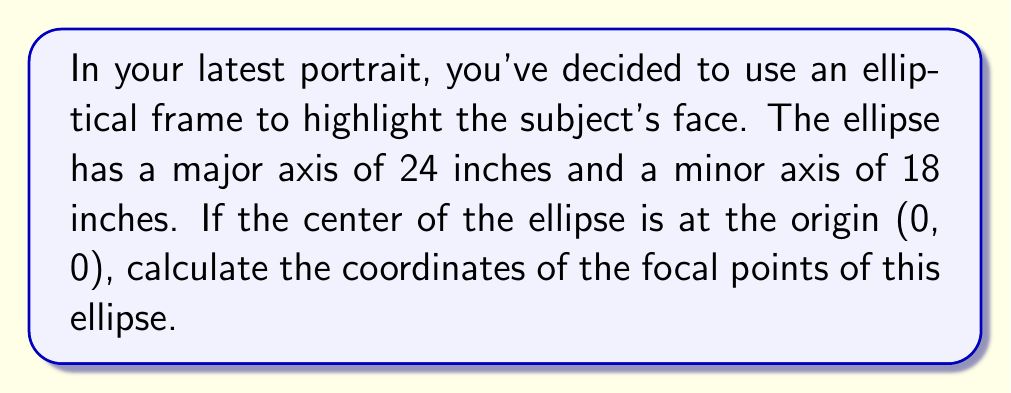Could you help me with this problem? Let's approach this step-by-step:

1) The general equation of an ellipse centered at the origin is:

   $$\frac{x^2}{a^2} + \frac{y^2}{b^2} = 1$$

   where $a$ is half the length of the major axis and $b$ is half the length of the minor axis.

2) In this case:
   $a = 24/2 = 12$ inches
   $b = 18/2 = 9$ inches

3) For an ellipse, the distance $c$ from the center to a focal point is given by:

   $$c^2 = a^2 - b^2$$

4) Substituting our values:

   $$c^2 = 12^2 - 9^2 = 144 - 81 = 63$$

5) Taking the square root:

   $$c = \sqrt{63} = 3\sqrt{7}$$

6) The focal points of an ellipse centered at the origin are located at $(±c, 0)$.

Therefore, the coordinates of the focal points are $(3\sqrt{7}, 0)$ and $(-3\sqrt{7}, 0)$.
Answer: $(±3\sqrt{7}, 0)$ 